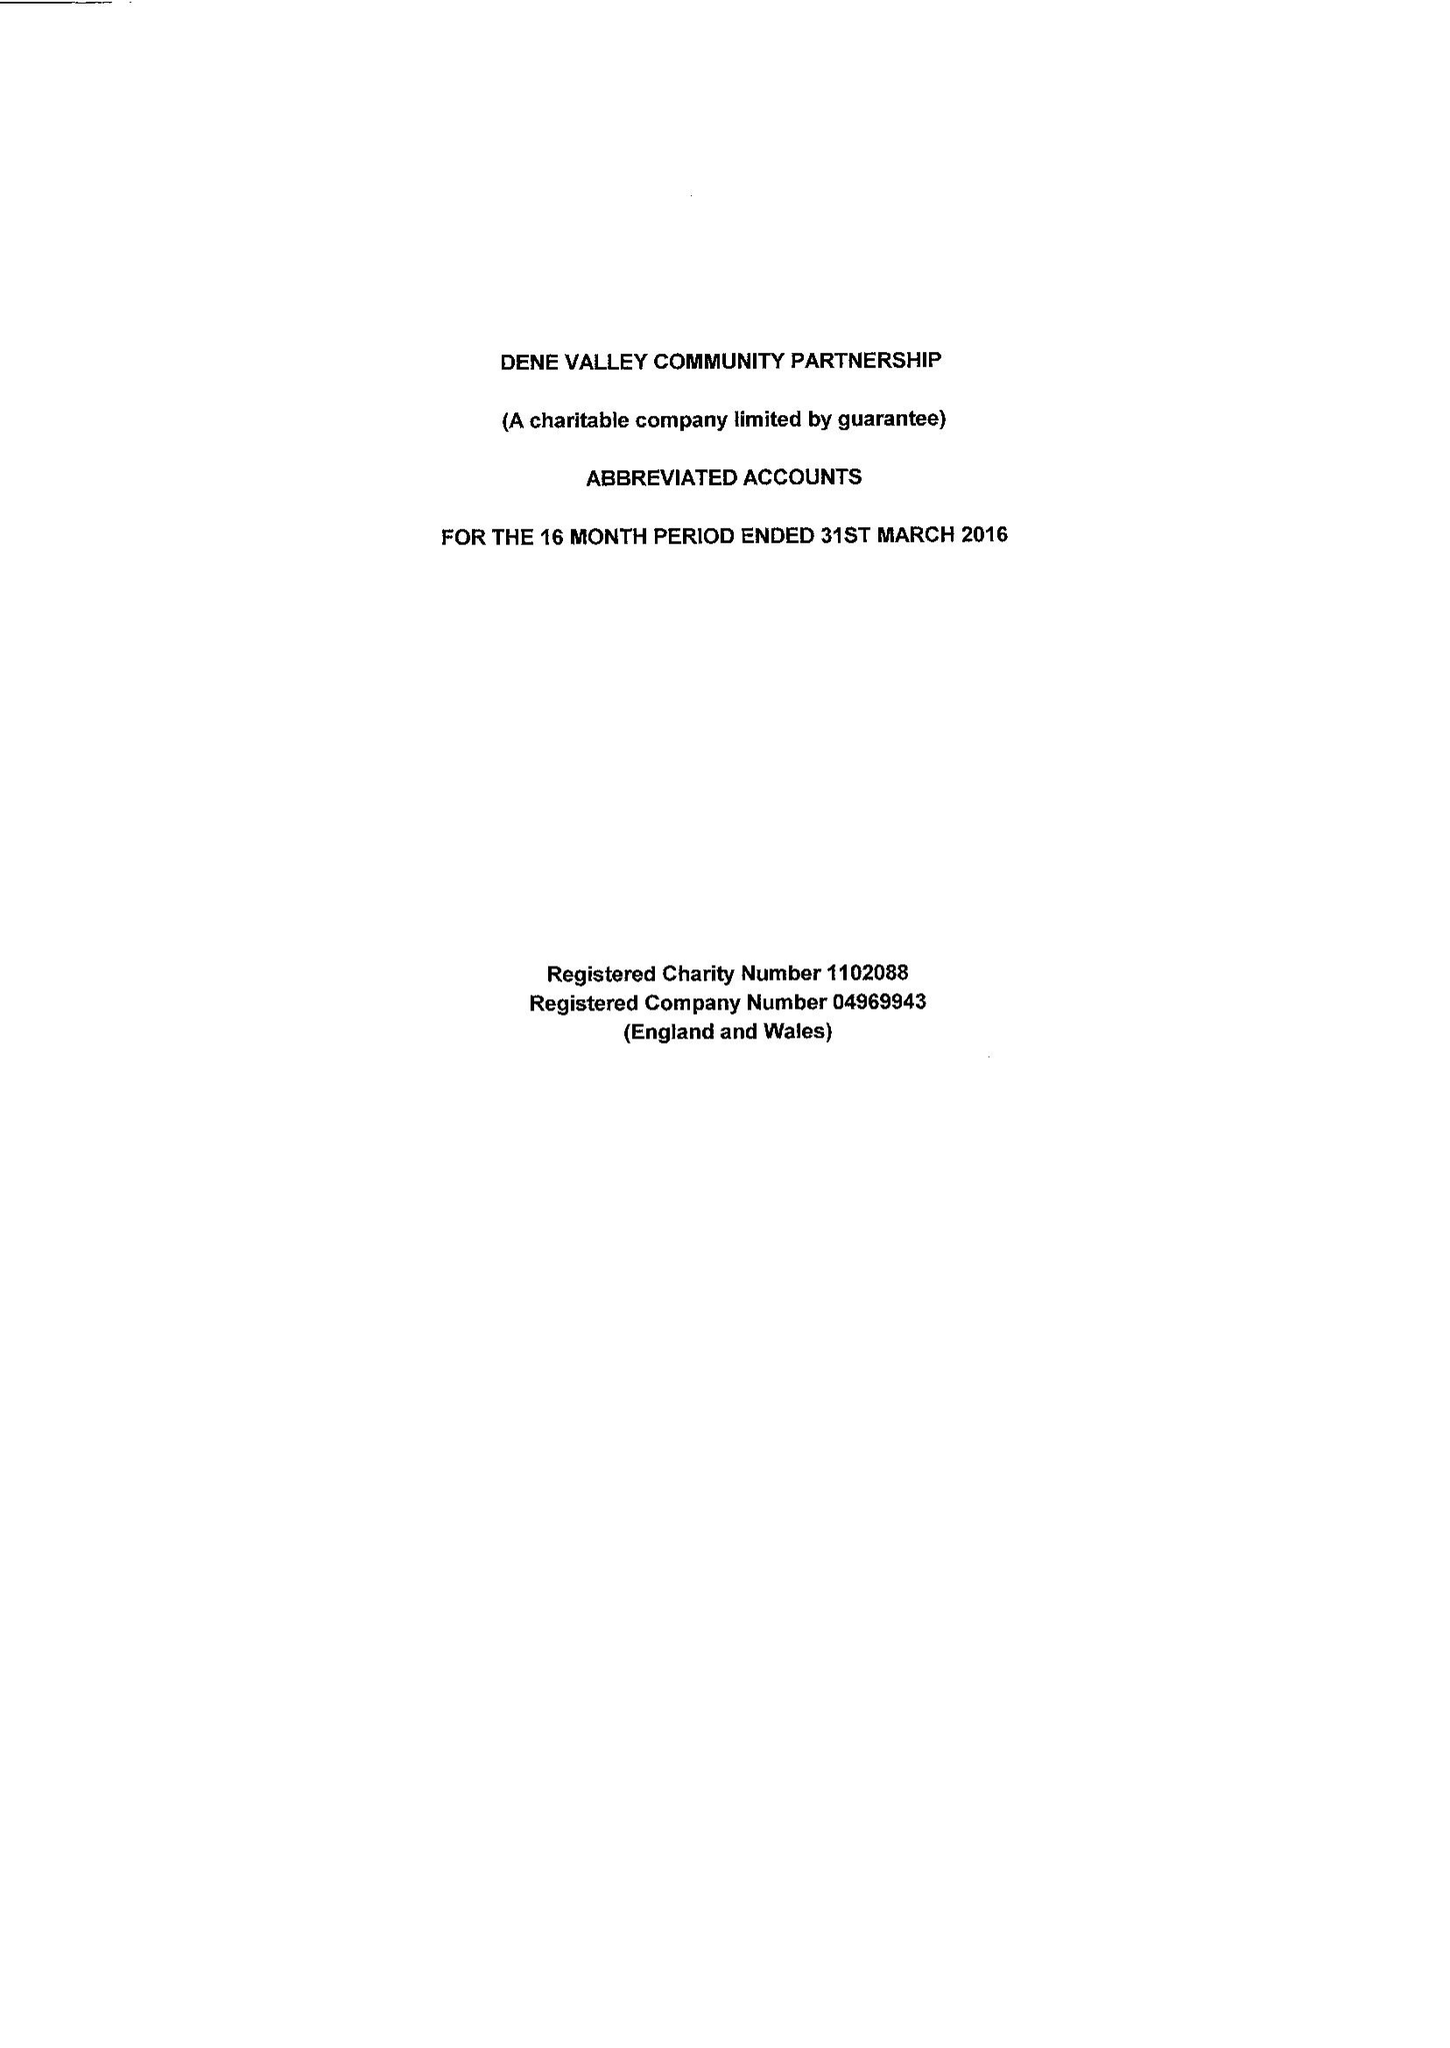What is the value for the spending_annually_in_british_pounds?
Answer the question using a single word or phrase. 49812.00 